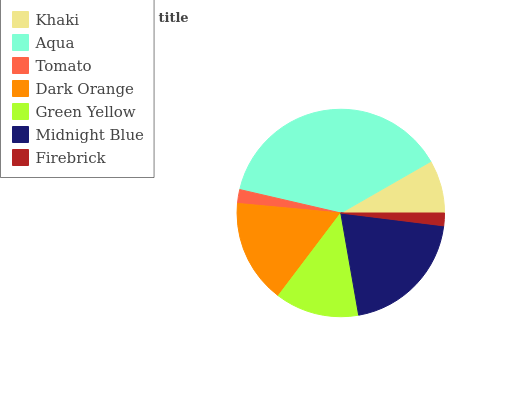Is Firebrick the minimum?
Answer yes or no. Yes. Is Aqua the maximum?
Answer yes or no. Yes. Is Tomato the minimum?
Answer yes or no. No. Is Tomato the maximum?
Answer yes or no. No. Is Aqua greater than Tomato?
Answer yes or no. Yes. Is Tomato less than Aqua?
Answer yes or no. Yes. Is Tomato greater than Aqua?
Answer yes or no. No. Is Aqua less than Tomato?
Answer yes or no. No. Is Green Yellow the high median?
Answer yes or no. Yes. Is Green Yellow the low median?
Answer yes or no. Yes. Is Dark Orange the high median?
Answer yes or no. No. Is Aqua the low median?
Answer yes or no. No. 